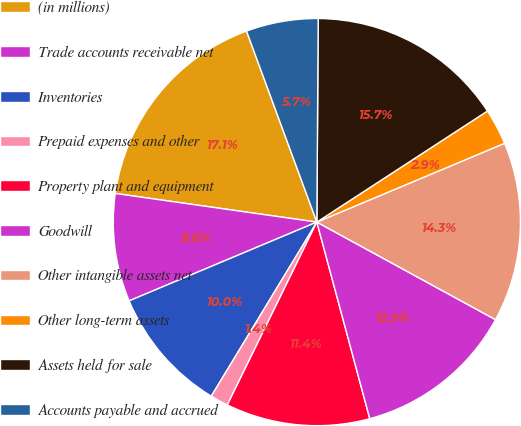<chart> <loc_0><loc_0><loc_500><loc_500><pie_chart><fcel>(in millions)<fcel>Trade accounts receivable net<fcel>Inventories<fcel>Prepaid expenses and other<fcel>Property plant and equipment<fcel>Goodwill<fcel>Other intangible assets net<fcel>Other long-term assets<fcel>Assets held for sale<fcel>Accounts payable and accrued<nl><fcel>17.14%<fcel>8.57%<fcel>10.0%<fcel>1.43%<fcel>11.43%<fcel>12.86%<fcel>14.28%<fcel>2.86%<fcel>15.71%<fcel>5.72%<nl></chart> 